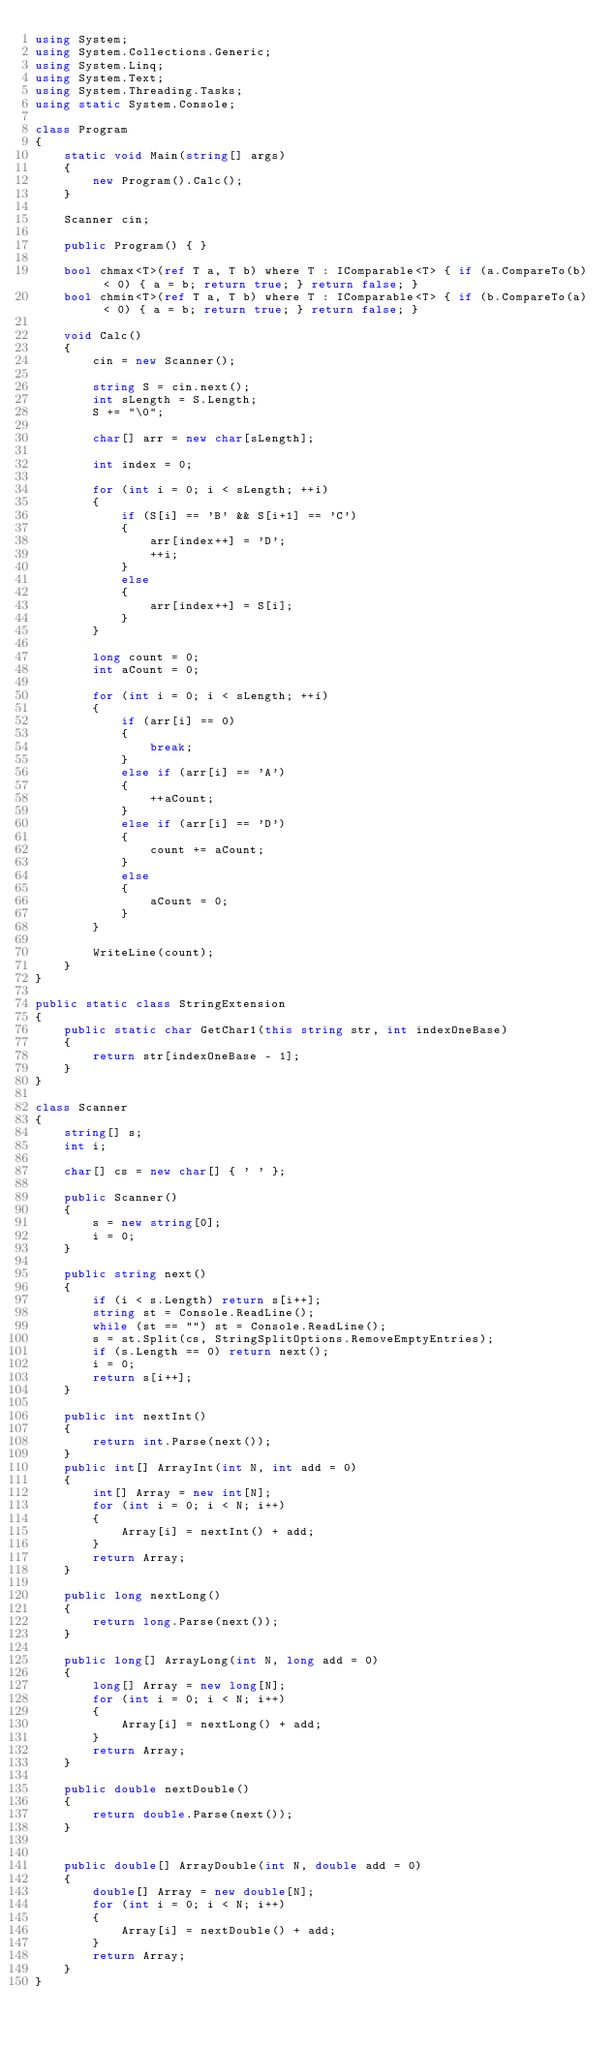<code> <loc_0><loc_0><loc_500><loc_500><_C#_>using System;
using System.Collections.Generic;
using System.Linq;
using System.Text;
using System.Threading.Tasks;
using static System.Console;

class Program
{
    static void Main(string[] args)
    {
        new Program().Calc();
    }

    Scanner cin;

    public Program() { }

    bool chmax<T>(ref T a, T b) where T : IComparable<T> { if (a.CompareTo(b) < 0) { a = b; return true; } return false; }
    bool chmin<T>(ref T a, T b) where T : IComparable<T> { if (b.CompareTo(a) < 0) { a = b; return true; } return false; }

    void Calc()
    {
        cin = new Scanner();

        string S = cin.next();
        int sLength = S.Length;
        S += "\0";

        char[] arr = new char[sLength];

        int index = 0;

        for (int i = 0; i < sLength; ++i)
        {
            if (S[i] == 'B' && S[i+1] == 'C')
            {
                arr[index++] = 'D';
                ++i;
            }
            else
            {
                arr[index++] = S[i];
            }
        }

        long count = 0;
        int aCount = 0;

        for (int i = 0; i < sLength; ++i)
        {
            if (arr[i] == 0)
            {
                break;
            }
            else if (arr[i] == 'A')
            {
                ++aCount;
            }
            else if (arr[i] == 'D')
            {
                count += aCount;
            }
            else
            {
                aCount = 0;
            }
        }

        WriteLine(count);
    }
}

public static class StringExtension
{
    public static char GetChar1(this string str, int indexOneBase)
    {
        return str[indexOneBase - 1];
    }
}

class Scanner
{
    string[] s;
    int i;

    char[] cs = new char[] { ' ' };

    public Scanner()
    {
        s = new string[0];
        i = 0;
    }

    public string next()
    {
        if (i < s.Length) return s[i++];
        string st = Console.ReadLine();
        while (st == "") st = Console.ReadLine();
        s = st.Split(cs, StringSplitOptions.RemoveEmptyEntries);
        if (s.Length == 0) return next();
        i = 0;
        return s[i++];
    }

    public int nextInt()
    {
        return int.Parse(next());
    }
    public int[] ArrayInt(int N, int add = 0)
    {
        int[] Array = new int[N];
        for (int i = 0; i < N; i++)
        {
            Array[i] = nextInt() + add;
        }
        return Array;
    }

    public long nextLong()
    {
        return long.Parse(next());
    }

    public long[] ArrayLong(int N, long add = 0)
    {
        long[] Array = new long[N];
        for (int i = 0; i < N; i++)
        {
            Array[i] = nextLong() + add;
        }
        return Array;
    }

    public double nextDouble()
    {
        return double.Parse(next());
    }


    public double[] ArrayDouble(int N, double add = 0)
    {
        double[] Array = new double[N];
        for (int i = 0; i < N; i++)
        {
            Array[i] = nextDouble() + add;
        }
        return Array;
    }
}
</code> 